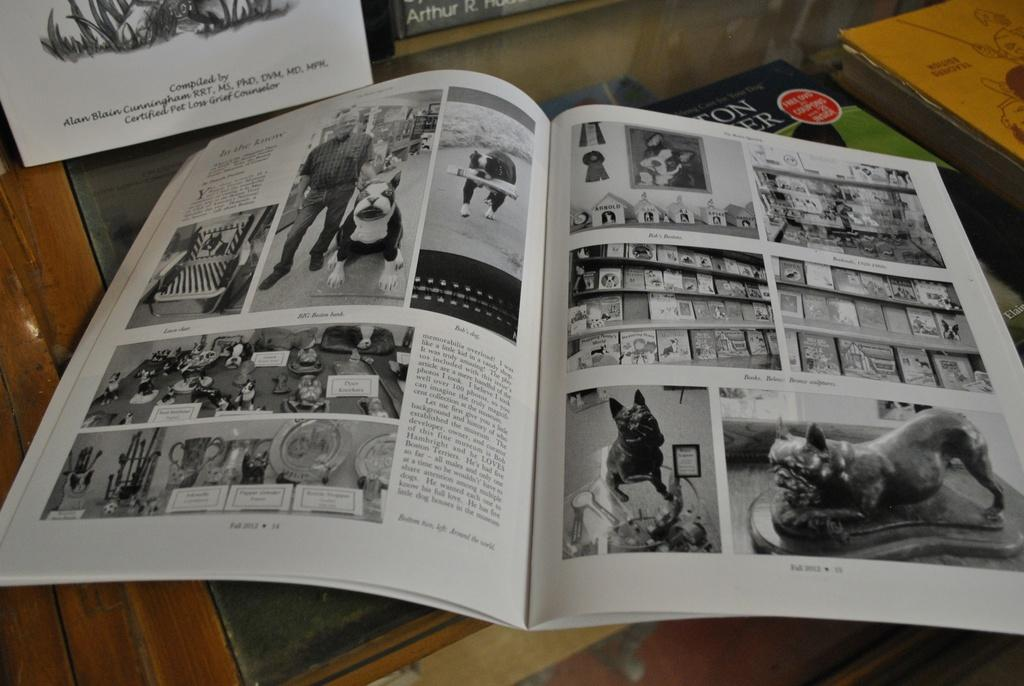Provide a one-sentence caption for the provided image. An open book with pictures and another behind it that was completed by Alan Blain Cunningham. 